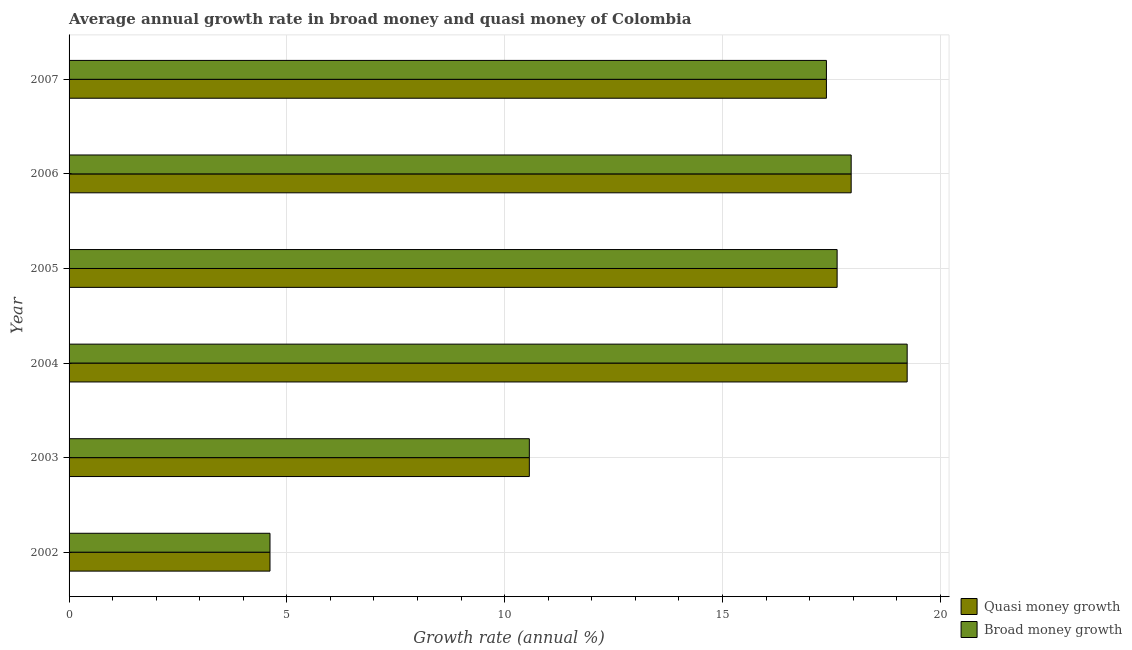How many different coloured bars are there?
Your answer should be very brief. 2. How many groups of bars are there?
Your answer should be very brief. 6. Are the number of bars per tick equal to the number of legend labels?
Ensure brevity in your answer.  Yes. What is the label of the 3rd group of bars from the top?
Provide a succinct answer. 2005. What is the annual growth rate in quasi money in 2006?
Provide a succinct answer. 17.95. Across all years, what is the maximum annual growth rate in quasi money?
Give a very brief answer. 19.24. Across all years, what is the minimum annual growth rate in quasi money?
Make the answer very short. 4.61. In which year was the annual growth rate in broad money minimum?
Provide a succinct answer. 2002. What is the total annual growth rate in quasi money in the graph?
Make the answer very short. 87.39. What is the difference between the annual growth rate in quasi money in 2005 and that in 2007?
Your answer should be very brief. 0.25. What is the difference between the annual growth rate in broad money in 2002 and the annual growth rate in quasi money in 2003?
Ensure brevity in your answer.  -5.95. What is the average annual growth rate in quasi money per year?
Offer a very short reply. 14.57. In the year 2006, what is the difference between the annual growth rate in quasi money and annual growth rate in broad money?
Offer a terse response. 0. What is the ratio of the annual growth rate in broad money in 2003 to that in 2004?
Make the answer very short. 0.55. Is the difference between the annual growth rate in broad money in 2002 and 2005 greater than the difference between the annual growth rate in quasi money in 2002 and 2005?
Provide a succinct answer. No. What is the difference between the highest and the second highest annual growth rate in broad money?
Make the answer very short. 1.28. What is the difference between the highest and the lowest annual growth rate in quasi money?
Offer a terse response. 14.63. In how many years, is the annual growth rate in broad money greater than the average annual growth rate in broad money taken over all years?
Provide a succinct answer. 4. What does the 1st bar from the top in 2003 represents?
Your response must be concise. Broad money growth. What does the 2nd bar from the bottom in 2005 represents?
Keep it short and to the point. Broad money growth. How many bars are there?
Give a very brief answer. 12. How many years are there in the graph?
Make the answer very short. 6. Are the values on the major ticks of X-axis written in scientific E-notation?
Ensure brevity in your answer.  No. Does the graph contain any zero values?
Keep it short and to the point. No. How are the legend labels stacked?
Provide a short and direct response. Vertical. What is the title of the graph?
Keep it short and to the point. Average annual growth rate in broad money and quasi money of Colombia. What is the label or title of the X-axis?
Your answer should be very brief. Growth rate (annual %). What is the label or title of the Y-axis?
Offer a very short reply. Year. What is the Growth rate (annual %) in Quasi money growth in 2002?
Make the answer very short. 4.61. What is the Growth rate (annual %) of Broad money growth in 2002?
Provide a succinct answer. 4.61. What is the Growth rate (annual %) of Quasi money growth in 2003?
Offer a terse response. 10.57. What is the Growth rate (annual %) in Broad money growth in 2003?
Offer a very short reply. 10.57. What is the Growth rate (annual %) of Quasi money growth in 2004?
Ensure brevity in your answer.  19.24. What is the Growth rate (annual %) in Broad money growth in 2004?
Provide a succinct answer. 19.24. What is the Growth rate (annual %) in Quasi money growth in 2005?
Ensure brevity in your answer.  17.63. What is the Growth rate (annual %) in Broad money growth in 2005?
Provide a short and direct response. 17.63. What is the Growth rate (annual %) in Quasi money growth in 2006?
Your answer should be very brief. 17.95. What is the Growth rate (annual %) of Broad money growth in 2006?
Offer a terse response. 17.95. What is the Growth rate (annual %) in Quasi money growth in 2007?
Make the answer very short. 17.39. What is the Growth rate (annual %) of Broad money growth in 2007?
Offer a very short reply. 17.39. Across all years, what is the maximum Growth rate (annual %) of Quasi money growth?
Your answer should be compact. 19.24. Across all years, what is the maximum Growth rate (annual %) of Broad money growth?
Provide a short and direct response. 19.24. Across all years, what is the minimum Growth rate (annual %) of Quasi money growth?
Give a very brief answer. 4.61. Across all years, what is the minimum Growth rate (annual %) of Broad money growth?
Ensure brevity in your answer.  4.61. What is the total Growth rate (annual %) in Quasi money growth in the graph?
Give a very brief answer. 87.39. What is the total Growth rate (annual %) in Broad money growth in the graph?
Your answer should be compact. 87.39. What is the difference between the Growth rate (annual %) in Quasi money growth in 2002 and that in 2003?
Your response must be concise. -5.95. What is the difference between the Growth rate (annual %) of Broad money growth in 2002 and that in 2003?
Offer a terse response. -5.95. What is the difference between the Growth rate (annual %) of Quasi money growth in 2002 and that in 2004?
Give a very brief answer. -14.63. What is the difference between the Growth rate (annual %) in Broad money growth in 2002 and that in 2004?
Your answer should be very brief. -14.63. What is the difference between the Growth rate (annual %) in Quasi money growth in 2002 and that in 2005?
Make the answer very short. -13.02. What is the difference between the Growth rate (annual %) of Broad money growth in 2002 and that in 2005?
Ensure brevity in your answer.  -13.02. What is the difference between the Growth rate (annual %) in Quasi money growth in 2002 and that in 2006?
Provide a short and direct response. -13.34. What is the difference between the Growth rate (annual %) in Broad money growth in 2002 and that in 2006?
Provide a succinct answer. -13.34. What is the difference between the Growth rate (annual %) of Quasi money growth in 2002 and that in 2007?
Make the answer very short. -12.77. What is the difference between the Growth rate (annual %) of Broad money growth in 2002 and that in 2007?
Your response must be concise. -12.77. What is the difference between the Growth rate (annual %) of Quasi money growth in 2003 and that in 2004?
Your answer should be very brief. -8.67. What is the difference between the Growth rate (annual %) of Broad money growth in 2003 and that in 2004?
Give a very brief answer. -8.67. What is the difference between the Growth rate (annual %) of Quasi money growth in 2003 and that in 2005?
Provide a short and direct response. -7.07. What is the difference between the Growth rate (annual %) of Broad money growth in 2003 and that in 2005?
Provide a short and direct response. -7.07. What is the difference between the Growth rate (annual %) in Quasi money growth in 2003 and that in 2006?
Your response must be concise. -7.39. What is the difference between the Growth rate (annual %) of Broad money growth in 2003 and that in 2006?
Your response must be concise. -7.39. What is the difference between the Growth rate (annual %) in Quasi money growth in 2003 and that in 2007?
Make the answer very short. -6.82. What is the difference between the Growth rate (annual %) of Broad money growth in 2003 and that in 2007?
Provide a short and direct response. -6.82. What is the difference between the Growth rate (annual %) in Quasi money growth in 2004 and that in 2005?
Your response must be concise. 1.61. What is the difference between the Growth rate (annual %) of Broad money growth in 2004 and that in 2005?
Keep it short and to the point. 1.61. What is the difference between the Growth rate (annual %) in Quasi money growth in 2004 and that in 2006?
Give a very brief answer. 1.29. What is the difference between the Growth rate (annual %) of Broad money growth in 2004 and that in 2006?
Ensure brevity in your answer.  1.29. What is the difference between the Growth rate (annual %) of Quasi money growth in 2004 and that in 2007?
Your answer should be very brief. 1.85. What is the difference between the Growth rate (annual %) of Broad money growth in 2004 and that in 2007?
Your response must be concise. 1.85. What is the difference between the Growth rate (annual %) in Quasi money growth in 2005 and that in 2006?
Your answer should be compact. -0.32. What is the difference between the Growth rate (annual %) in Broad money growth in 2005 and that in 2006?
Your response must be concise. -0.32. What is the difference between the Growth rate (annual %) of Quasi money growth in 2005 and that in 2007?
Provide a short and direct response. 0.25. What is the difference between the Growth rate (annual %) in Broad money growth in 2005 and that in 2007?
Make the answer very short. 0.25. What is the difference between the Growth rate (annual %) in Quasi money growth in 2006 and that in 2007?
Make the answer very short. 0.57. What is the difference between the Growth rate (annual %) in Broad money growth in 2006 and that in 2007?
Your answer should be very brief. 0.57. What is the difference between the Growth rate (annual %) of Quasi money growth in 2002 and the Growth rate (annual %) of Broad money growth in 2003?
Your answer should be very brief. -5.95. What is the difference between the Growth rate (annual %) of Quasi money growth in 2002 and the Growth rate (annual %) of Broad money growth in 2004?
Provide a succinct answer. -14.63. What is the difference between the Growth rate (annual %) in Quasi money growth in 2002 and the Growth rate (annual %) in Broad money growth in 2005?
Offer a terse response. -13.02. What is the difference between the Growth rate (annual %) of Quasi money growth in 2002 and the Growth rate (annual %) of Broad money growth in 2006?
Offer a very short reply. -13.34. What is the difference between the Growth rate (annual %) of Quasi money growth in 2002 and the Growth rate (annual %) of Broad money growth in 2007?
Your answer should be very brief. -12.77. What is the difference between the Growth rate (annual %) in Quasi money growth in 2003 and the Growth rate (annual %) in Broad money growth in 2004?
Make the answer very short. -8.67. What is the difference between the Growth rate (annual %) of Quasi money growth in 2003 and the Growth rate (annual %) of Broad money growth in 2005?
Ensure brevity in your answer.  -7.07. What is the difference between the Growth rate (annual %) of Quasi money growth in 2003 and the Growth rate (annual %) of Broad money growth in 2006?
Provide a short and direct response. -7.39. What is the difference between the Growth rate (annual %) of Quasi money growth in 2003 and the Growth rate (annual %) of Broad money growth in 2007?
Provide a succinct answer. -6.82. What is the difference between the Growth rate (annual %) in Quasi money growth in 2004 and the Growth rate (annual %) in Broad money growth in 2005?
Offer a very short reply. 1.61. What is the difference between the Growth rate (annual %) of Quasi money growth in 2004 and the Growth rate (annual %) of Broad money growth in 2006?
Provide a succinct answer. 1.29. What is the difference between the Growth rate (annual %) of Quasi money growth in 2004 and the Growth rate (annual %) of Broad money growth in 2007?
Make the answer very short. 1.85. What is the difference between the Growth rate (annual %) in Quasi money growth in 2005 and the Growth rate (annual %) in Broad money growth in 2006?
Keep it short and to the point. -0.32. What is the difference between the Growth rate (annual %) of Quasi money growth in 2005 and the Growth rate (annual %) of Broad money growth in 2007?
Offer a very short reply. 0.25. What is the difference between the Growth rate (annual %) of Quasi money growth in 2006 and the Growth rate (annual %) of Broad money growth in 2007?
Keep it short and to the point. 0.57. What is the average Growth rate (annual %) of Quasi money growth per year?
Your response must be concise. 14.57. What is the average Growth rate (annual %) in Broad money growth per year?
Your answer should be compact. 14.57. In the year 2003, what is the difference between the Growth rate (annual %) of Quasi money growth and Growth rate (annual %) of Broad money growth?
Ensure brevity in your answer.  0. In the year 2005, what is the difference between the Growth rate (annual %) in Quasi money growth and Growth rate (annual %) in Broad money growth?
Keep it short and to the point. 0. In the year 2007, what is the difference between the Growth rate (annual %) of Quasi money growth and Growth rate (annual %) of Broad money growth?
Ensure brevity in your answer.  0. What is the ratio of the Growth rate (annual %) in Quasi money growth in 2002 to that in 2003?
Your answer should be very brief. 0.44. What is the ratio of the Growth rate (annual %) of Broad money growth in 2002 to that in 2003?
Provide a short and direct response. 0.44. What is the ratio of the Growth rate (annual %) of Quasi money growth in 2002 to that in 2004?
Your answer should be compact. 0.24. What is the ratio of the Growth rate (annual %) of Broad money growth in 2002 to that in 2004?
Offer a very short reply. 0.24. What is the ratio of the Growth rate (annual %) in Quasi money growth in 2002 to that in 2005?
Make the answer very short. 0.26. What is the ratio of the Growth rate (annual %) of Broad money growth in 2002 to that in 2005?
Keep it short and to the point. 0.26. What is the ratio of the Growth rate (annual %) in Quasi money growth in 2002 to that in 2006?
Provide a short and direct response. 0.26. What is the ratio of the Growth rate (annual %) of Broad money growth in 2002 to that in 2006?
Offer a very short reply. 0.26. What is the ratio of the Growth rate (annual %) of Quasi money growth in 2002 to that in 2007?
Your answer should be compact. 0.27. What is the ratio of the Growth rate (annual %) of Broad money growth in 2002 to that in 2007?
Keep it short and to the point. 0.27. What is the ratio of the Growth rate (annual %) of Quasi money growth in 2003 to that in 2004?
Keep it short and to the point. 0.55. What is the ratio of the Growth rate (annual %) of Broad money growth in 2003 to that in 2004?
Your answer should be compact. 0.55. What is the ratio of the Growth rate (annual %) in Quasi money growth in 2003 to that in 2005?
Make the answer very short. 0.6. What is the ratio of the Growth rate (annual %) in Broad money growth in 2003 to that in 2005?
Provide a succinct answer. 0.6. What is the ratio of the Growth rate (annual %) in Quasi money growth in 2003 to that in 2006?
Make the answer very short. 0.59. What is the ratio of the Growth rate (annual %) of Broad money growth in 2003 to that in 2006?
Give a very brief answer. 0.59. What is the ratio of the Growth rate (annual %) of Quasi money growth in 2003 to that in 2007?
Keep it short and to the point. 0.61. What is the ratio of the Growth rate (annual %) in Broad money growth in 2003 to that in 2007?
Your answer should be compact. 0.61. What is the ratio of the Growth rate (annual %) of Quasi money growth in 2004 to that in 2005?
Give a very brief answer. 1.09. What is the ratio of the Growth rate (annual %) of Broad money growth in 2004 to that in 2005?
Make the answer very short. 1.09. What is the ratio of the Growth rate (annual %) in Quasi money growth in 2004 to that in 2006?
Provide a succinct answer. 1.07. What is the ratio of the Growth rate (annual %) of Broad money growth in 2004 to that in 2006?
Provide a succinct answer. 1.07. What is the ratio of the Growth rate (annual %) of Quasi money growth in 2004 to that in 2007?
Give a very brief answer. 1.11. What is the ratio of the Growth rate (annual %) of Broad money growth in 2004 to that in 2007?
Keep it short and to the point. 1.11. What is the ratio of the Growth rate (annual %) in Quasi money growth in 2005 to that in 2006?
Ensure brevity in your answer.  0.98. What is the ratio of the Growth rate (annual %) of Broad money growth in 2005 to that in 2006?
Give a very brief answer. 0.98. What is the ratio of the Growth rate (annual %) of Quasi money growth in 2005 to that in 2007?
Your answer should be compact. 1.01. What is the ratio of the Growth rate (annual %) in Broad money growth in 2005 to that in 2007?
Ensure brevity in your answer.  1.01. What is the ratio of the Growth rate (annual %) in Quasi money growth in 2006 to that in 2007?
Make the answer very short. 1.03. What is the ratio of the Growth rate (annual %) in Broad money growth in 2006 to that in 2007?
Provide a succinct answer. 1.03. What is the difference between the highest and the second highest Growth rate (annual %) in Quasi money growth?
Offer a very short reply. 1.29. What is the difference between the highest and the second highest Growth rate (annual %) of Broad money growth?
Make the answer very short. 1.29. What is the difference between the highest and the lowest Growth rate (annual %) in Quasi money growth?
Give a very brief answer. 14.63. What is the difference between the highest and the lowest Growth rate (annual %) in Broad money growth?
Give a very brief answer. 14.63. 